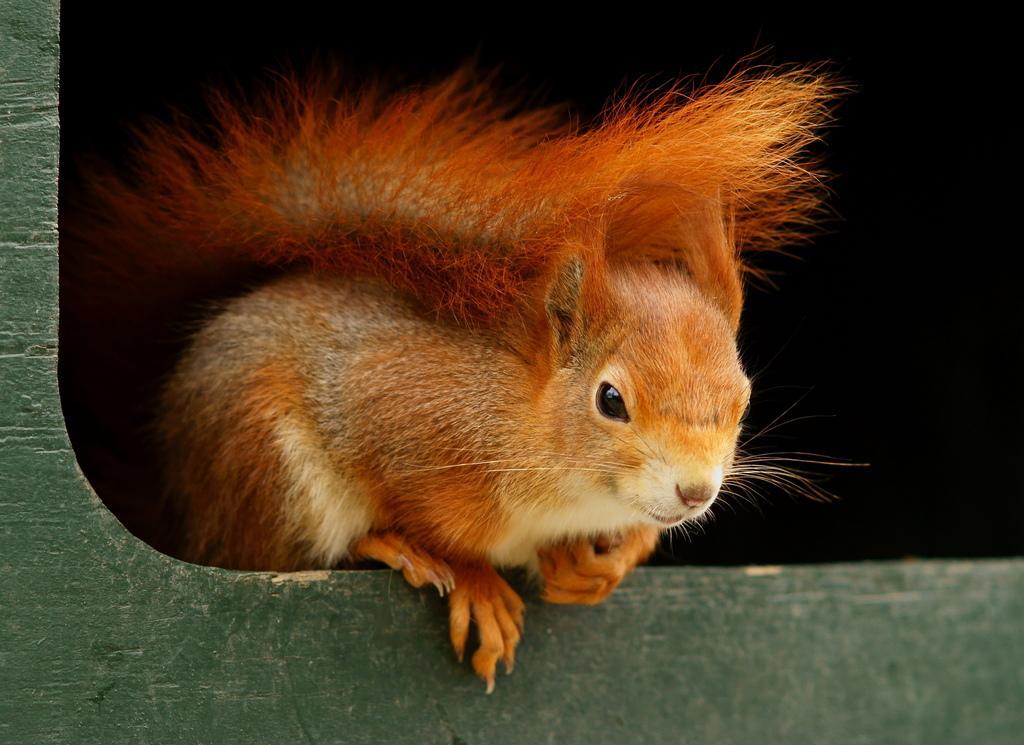Please provide a concise description of this image. In the center of this picture we can see a squirrel on an object. The background of the image is black in color. 